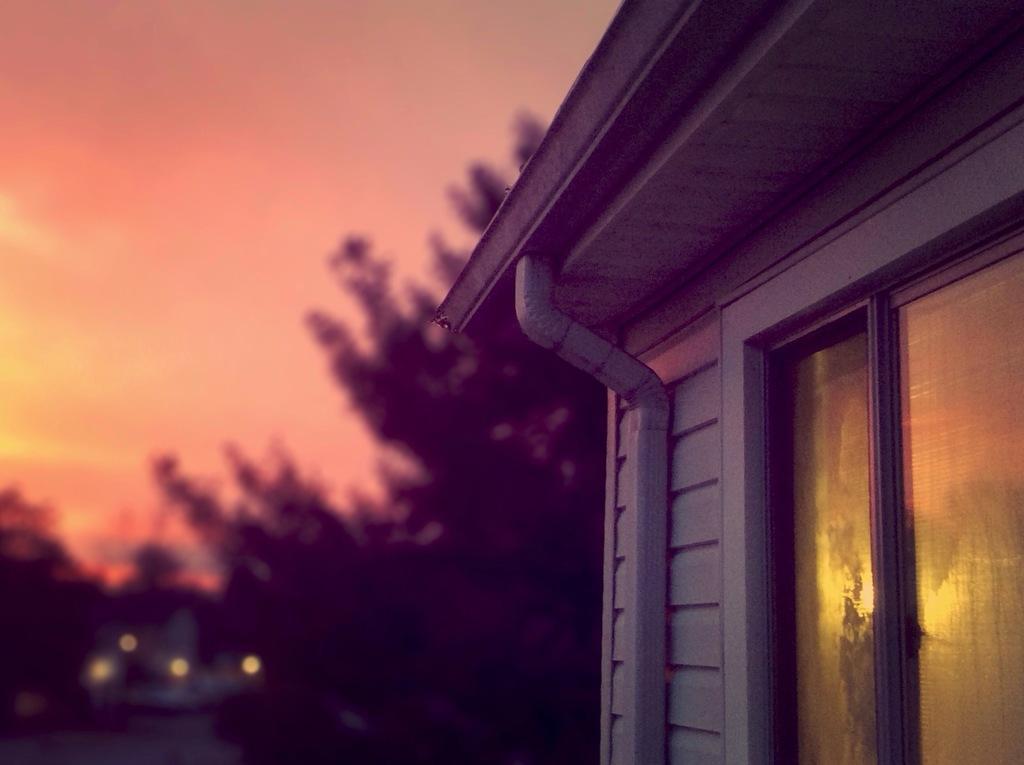Could you give a brief overview of what you see in this image? In this image I can see a building and in the background I can see a tree. I can also this image is little bit blurry from background. 